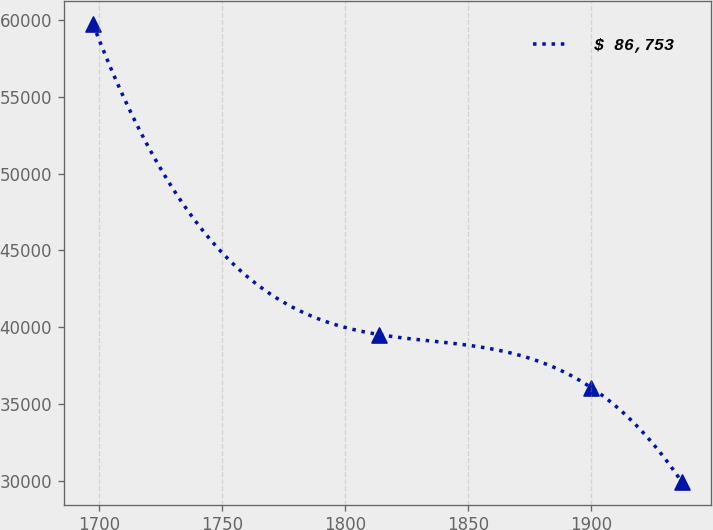<chart> <loc_0><loc_0><loc_500><loc_500><line_chart><ecel><fcel>$ 86,753<nl><fcel>1697.56<fcel>59735<nl><fcel>1813.71<fcel>39518.7<nl><fcel>1900.07<fcel>36064.6<nl><fcel>1936.87<fcel>29928.1<nl></chart> 